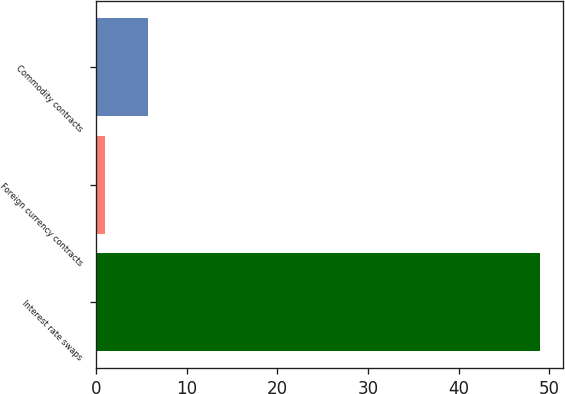Convert chart. <chart><loc_0><loc_0><loc_500><loc_500><bar_chart><fcel>Interest rate swaps<fcel>Foreign currency contracts<fcel>Commodity contracts<nl><fcel>49<fcel>1<fcel>5.8<nl></chart> 